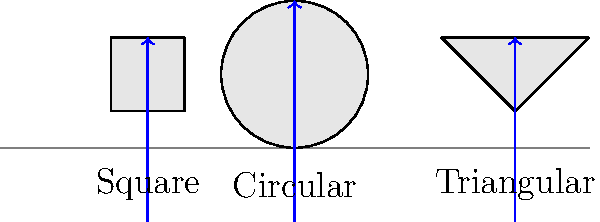During a live performance, you notice three different shaped spotlights on the stage: circular, square, and triangular. Assuming all spotlights use the same type of lens material, how would the refraction of light differ between these shapes, and which shape would likely provide the most uniform illumination on the stage? To answer this question, let's consider the principles of refraction and how they apply to different lens shapes:

1. Refraction basics:
   - Light bends when it passes from one medium to another with a different refractive index.
   - The amount of bending depends on the angle of incidence and the shape of the interface.

2. Circular spotlight:
   - Circular lenses have a symmetrical shape.
   - Light rays passing through the center are not refracted.
   - Rays away from the center are refracted equally in all directions.
   - This results in a uniform distribution of light.

3. Square spotlight:
   - Square lenses have sharp corners and flat edges.
   - Light rays passing through the center of each edge are not refracted much.
   - Rays passing through corners experience more refraction.
   - This can lead to slightly uneven illumination, with more light concentrated at the corners.

4. Triangular spotlight:
   - Triangular lenses have three sharp corners and flat edges.
   - Light rays passing through the center of each edge are refracted less than those passing through the corners.
   - This shape can create the most uneven distribution of light among the three options.

5. Uniformity comparison:
   - Circular shape: Most uniform illumination due to its symmetry.
   - Square shape: Less uniform than circular, but still relatively even.
   - Triangular shape: Least uniform, with potential hot spots at the corners.

Therefore, the circular spotlight would likely provide the most uniform illumination on the stage.
Answer: Circular spotlight provides the most uniform illumination due to symmetrical refraction. 